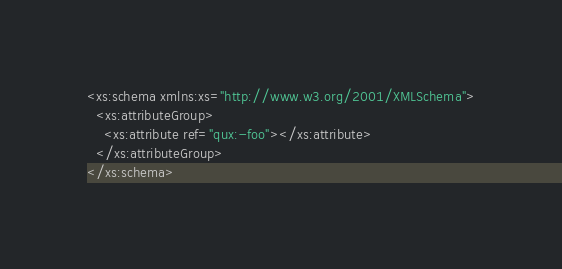<code> <loc_0><loc_0><loc_500><loc_500><_XML_><xs:schema xmlns:xs="http://www.w3.org/2001/XMLSchema">
  <xs:attributeGroup>
    <xs:attribute ref="qux:-foo"></xs:attribute>
  </xs:attributeGroup>
</xs:schema>
</code> 